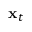<formula> <loc_0><loc_0><loc_500><loc_500>x _ { t }</formula> 